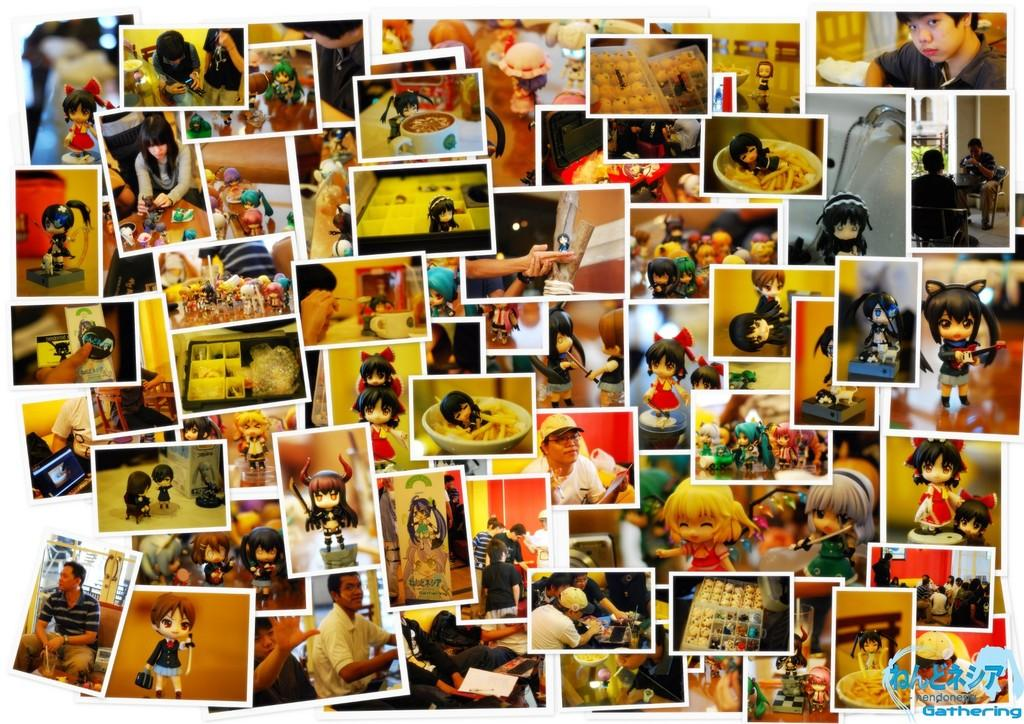What is the main subject of the image? The main subject of the image is multiple photographs. What types of items can be seen in the photographs? The photographs contain people, toys, food, and various objects. Where is the watermark located in the image? The watermark is in the bottom right corner of the image. What type of weight can be seen in the image? There is no weight present in the image; it contains photographs with various items, such as people, toys, food, and objects. What musical instrument is being played in the image? There is no musical instrument being played in the image, as it contains photographs with various items and no live action. 